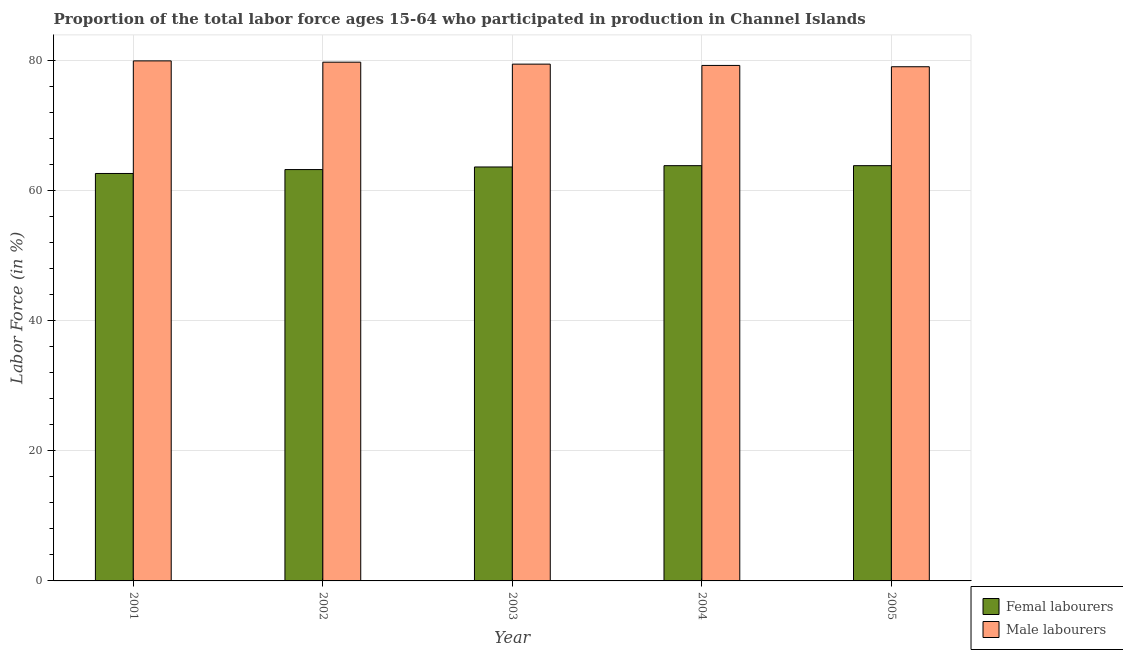How many different coloured bars are there?
Make the answer very short. 2. How many groups of bars are there?
Ensure brevity in your answer.  5. Are the number of bars per tick equal to the number of legend labels?
Provide a short and direct response. Yes. How many bars are there on the 3rd tick from the left?
Keep it short and to the point. 2. What is the label of the 1st group of bars from the left?
Provide a succinct answer. 2001. In how many cases, is the number of bars for a given year not equal to the number of legend labels?
Offer a very short reply. 0. What is the percentage of female labor force in 2003?
Give a very brief answer. 63.6. Across all years, what is the maximum percentage of male labour force?
Offer a terse response. 79.9. Across all years, what is the minimum percentage of male labour force?
Ensure brevity in your answer.  79. In which year was the percentage of female labor force maximum?
Your answer should be very brief. 2004. What is the total percentage of male labour force in the graph?
Your answer should be compact. 397.2. What is the difference between the percentage of female labor force in 2004 and that in 2005?
Provide a short and direct response. 0. What is the difference between the percentage of male labour force in 2005 and the percentage of female labor force in 2001?
Keep it short and to the point. -0.9. What is the average percentage of female labor force per year?
Keep it short and to the point. 63.4. What is the ratio of the percentage of female labor force in 2002 to that in 2005?
Offer a terse response. 0.99. What is the difference between the highest and the second highest percentage of male labour force?
Make the answer very short. 0.2. What is the difference between the highest and the lowest percentage of male labour force?
Offer a very short reply. 0.9. In how many years, is the percentage of female labor force greater than the average percentage of female labor force taken over all years?
Offer a very short reply. 3. What does the 1st bar from the left in 2002 represents?
Keep it short and to the point. Femal labourers. What does the 1st bar from the right in 2005 represents?
Give a very brief answer. Male labourers. Are all the bars in the graph horizontal?
Your answer should be compact. No. Does the graph contain any zero values?
Keep it short and to the point. No. Where does the legend appear in the graph?
Give a very brief answer. Bottom right. How many legend labels are there?
Offer a terse response. 2. How are the legend labels stacked?
Keep it short and to the point. Vertical. What is the title of the graph?
Your response must be concise. Proportion of the total labor force ages 15-64 who participated in production in Channel Islands. Does "From World Bank" appear as one of the legend labels in the graph?
Give a very brief answer. No. What is the Labor Force (in %) in Femal labourers in 2001?
Offer a very short reply. 62.6. What is the Labor Force (in %) in Male labourers in 2001?
Make the answer very short. 79.9. What is the Labor Force (in %) in Femal labourers in 2002?
Your answer should be compact. 63.2. What is the Labor Force (in %) of Male labourers in 2002?
Your answer should be compact. 79.7. What is the Labor Force (in %) in Femal labourers in 2003?
Keep it short and to the point. 63.6. What is the Labor Force (in %) of Male labourers in 2003?
Offer a very short reply. 79.4. What is the Labor Force (in %) in Femal labourers in 2004?
Your response must be concise. 63.8. What is the Labor Force (in %) in Male labourers in 2004?
Your answer should be compact. 79.2. What is the Labor Force (in %) of Femal labourers in 2005?
Keep it short and to the point. 63.8. What is the Labor Force (in %) of Male labourers in 2005?
Your response must be concise. 79. Across all years, what is the maximum Labor Force (in %) of Femal labourers?
Keep it short and to the point. 63.8. Across all years, what is the maximum Labor Force (in %) of Male labourers?
Provide a short and direct response. 79.9. Across all years, what is the minimum Labor Force (in %) of Femal labourers?
Your answer should be very brief. 62.6. Across all years, what is the minimum Labor Force (in %) of Male labourers?
Provide a short and direct response. 79. What is the total Labor Force (in %) of Femal labourers in the graph?
Provide a short and direct response. 317. What is the total Labor Force (in %) in Male labourers in the graph?
Offer a terse response. 397.2. What is the difference between the Labor Force (in %) of Femal labourers in 2001 and that in 2002?
Provide a succinct answer. -0.6. What is the difference between the Labor Force (in %) in Male labourers in 2001 and that in 2002?
Ensure brevity in your answer.  0.2. What is the difference between the Labor Force (in %) in Male labourers in 2001 and that in 2003?
Give a very brief answer. 0.5. What is the difference between the Labor Force (in %) in Femal labourers in 2001 and that in 2004?
Provide a short and direct response. -1.2. What is the difference between the Labor Force (in %) in Male labourers in 2001 and that in 2004?
Offer a very short reply. 0.7. What is the difference between the Labor Force (in %) of Femal labourers in 2002 and that in 2003?
Give a very brief answer. -0.4. What is the difference between the Labor Force (in %) in Male labourers in 2002 and that in 2003?
Offer a terse response. 0.3. What is the difference between the Labor Force (in %) of Femal labourers in 2002 and that in 2004?
Offer a very short reply. -0.6. What is the difference between the Labor Force (in %) in Femal labourers in 2002 and that in 2005?
Ensure brevity in your answer.  -0.6. What is the difference between the Labor Force (in %) in Male labourers in 2003 and that in 2004?
Offer a terse response. 0.2. What is the difference between the Labor Force (in %) of Male labourers in 2004 and that in 2005?
Offer a terse response. 0.2. What is the difference between the Labor Force (in %) in Femal labourers in 2001 and the Labor Force (in %) in Male labourers in 2002?
Ensure brevity in your answer.  -17.1. What is the difference between the Labor Force (in %) of Femal labourers in 2001 and the Labor Force (in %) of Male labourers in 2003?
Keep it short and to the point. -16.8. What is the difference between the Labor Force (in %) in Femal labourers in 2001 and the Labor Force (in %) in Male labourers in 2004?
Your answer should be compact. -16.6. What is the difference between the Labor Force (in %) of Femal labourers in 2001 and the Labor Force (in %) of Male labourers in 2005?
Your answer should be very brief. -16.4. What is the difference between the Labor Force (in %) in Femal labourers in 2002 and the Labor Force (in %) in Male labourers in 2003?
Ensure brevity in your answer.  -16.2. What is the difference between the Labor Force (in %) of Femal labourers in 2002 and the Labor Force (in %) of Male labourers in 2005?
Offer a terse response. -15.8. What is the difference between the Labor Force (in %) in Femal labourers in 2003 and the Labor Force (in %) in Male labourers in 2004?
Give a very brief answer. -15.6. What is the difference between the Labor Force (in %) in Femal labourers in 2003 and the Labor Force (in %) in Male labourers in 2005?
Give a very brief answer. -15.4. What is the difference between the Labor Force (in %) of Femal labourers in 2004 and the Labor Force (in %) of Male labourers in 2005?
Keep it short and to the point. -15.2. What is the average Labor Force (in %) in Femal labourers per year?
Your answer should be compact. 63.4. What is the average Labor Force (in %) in Male labourers per year?
Your response must be concise. 79.44. In the year 2001, what is the difference between the Labor Force (in %) in Femal labourers and Labor Force (in %) in Male labourers?
Make the answer very short. -17.3. In the year 2002, what is the difference between the Labor Force (in %) in Femal labourers and Labor Force (in %) in Male labourers?
Provide a succinct answer. -16.5. In the year 2003, what is the difference between the Labor Force (in %) of Femal labourers and Labor Force (in %) of Male labourers?
Ensure brevity in your answer.  -15.8. In the year 2004, what is the difference between the Labor Force (in %) in Femal labourers and Labor Force (in %) in Male labourers?
Ensure brevity in your answer.  -15.4. In the year 2005, what is the difference between the Labor Force (in %) in Femal labourers and Labor Force (in %) in Male labourers?
Your answer should be very brief. -15.2. What is the ratio of the Labor Force (in %) of Femal labourers in 2001 to that in 2002?
Ensure brevity in your answer.  0.99. What is the ratio of the Labor Force (in %) in Femal labourers in 2001 to that in 2003?
Offer a terse response. 0.98. What is the ratio of the Labor Force (in %) in Male labourers in 2001 to that in 2003?
Offer a terse response. 1.01. What is the ratio of the Labor Force (in %) in Femal labourers in 2001 to that in 2004?
Your answer should be very brief. 0.98. What is the ratio of the Labor Force (in %) of Male labourers in 2001 to that in 2004?
Your response must be concise. 1.01. What is the ratio of the Labor Force (in %) of Femal labourers in 2001 to that in 2005?
Your answer should be compact. 0.98. What is the ratio of the Labor Force (in %) of Male labourers in 2001 to that in 2005?
Make the answer very short. 1.01. What is the ratio of the Labor Force (in %) in Male labourers in 2002 to that in 2003?
Offer a terse response. 1. What is the ratio of the Labor Force (in %) in Femal labourers in 2002 to that in 2004?
Make the answer very short. 0.99. What is the ratio of the Labor Force (in %) in Male labourers in 2002 to that in 2004?
Ensure brevity in your answer.  1.01. What is the ratio of the Labor Force (in %) of Femal labourers in 2002 to that in 2005?
Offer a very short reply. 0.99. What is the ratio of the Labor Force (in %) in Male labourers in 2002 to that in 2005?
Provide a short and direct response. 1.01. What is the ratio of the Labor Force (in %) in Femal labourers in 2003 to that in 2004?
Provide a short and direct response. 1. What is the ratio of the Labor Force (in %) in Male labourers in 2003 to that in 2004?
Ensure brevity in your answer.  1. What is the ratio of the Labor Force (in %) in Male labourers in 2003 to that in 2005?
Provide a short and direct response. 1.01. 